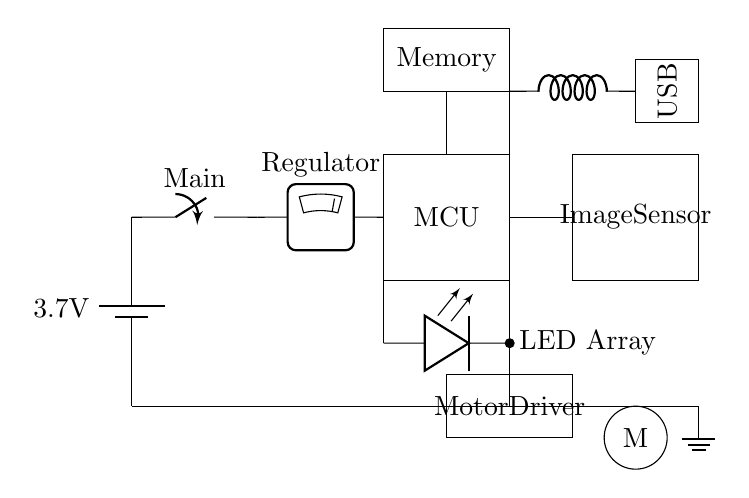What is the voltage of the battery? The battery in the circuit is labeled with a voltage of 3.7 volts, which indicates the electrical potential provided to the rest of the components.
Answer: 3.7 volts What is the function of the MCU? The microcontroller unit (MCU) is responsible for controlling the operation of the scanner, processing signals from the image sensor, managing the LED array, and coordinating the motor movement.
Answer: Control Which component regulates the voltage? The voltage regulator, which is connected directly after the main switch, ensures that the correct voltage is supplied to the microcontroller and other components, stabilizing the power supply.
Answer: Regulator What type of interface is present in the circuit? A USB interface is shown in the circuit, allowing the scanner to connect to other devices for data transfer, which is essential in a document scanning application.
Answer: USB What is the role of the image sensor? The image sensor captures the images of documents that are being scanned, converting light into electronic signals for processing by the microcontroller.
Answer: Capture images How does the LED array interact with the image sensor? The LED array provides the necessary illumination for the image sensor to effectively capture clear images of the documents, ensuring good visibility during the scanning process.
Answer: Illuminate Why is a low-power design important for this device? Low-power design is crucial for portable devices like this document scanner as it prolongs battery life, reduces heat generation, and enhances overall efficiency, making it more user-friendly and practical.
Answer: Efficiency 